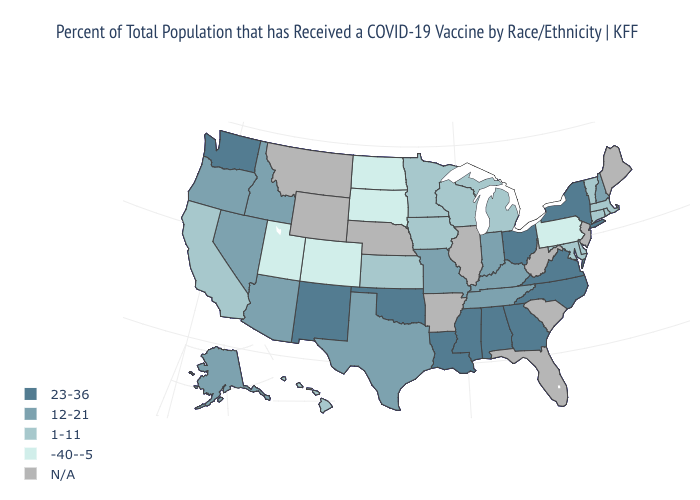What is the lowest value in states that border New Hampshire?
Keep it brief. 1-11. Name the states that have a value in the range 12-21?
Short answer required. Alaska, Arizona, Idaho, Indiana, Kentucky, Missouri, Nevada, New Hampshire, Oregon, Tennessee, Texas. What is the value of New Mexico?
Short answer required. 23-36. Does the first symbol in the legend represent the smallest category?
Quick response, please. No. Name the states that have a value in the range 23-36?
Answer briefly. Alabama, Georgia, Louisiana, Mississippi, New Mexico, New York, North Carolina, Ohio, Oklahoma, Virginia, Washington. Which states have the lowest value in the USA?
Answer briefly. Colorado, North Dakota, Pennsylvania, South Dakota, Utah. Does Mississippi have the highest value in the USA?
Answer briefly. Yes. Does Tennessee have the highest value in the USA?
Concise answer only. No. What is the highest value in the West ?
Keep it brief. 23-36. What is the highest value in states that border Virginia?
Quick response, please. 23-36. Among the states that border Delaware , does Pennsylvania have the highest value?
Short answer required. No. Does Tennessee have the lowest value in the South?
Keep it brief. No. Name the states that have a value in the range 23-36?
Be succinct. Alabama, Georgia, Louisiana, Mississippi, New Mexico, New York, North Carolina, Ohio, Oklahoma, Virginia, Washington. 